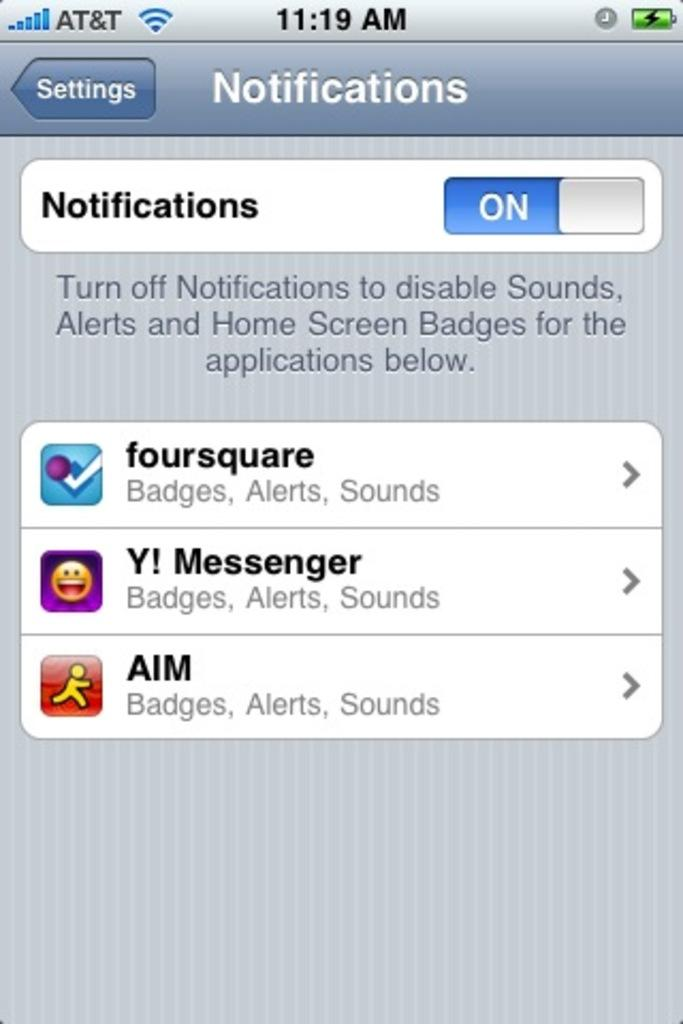<image>
Render a clear and concise summary of the photo. The owner of this phone uses Foursquare, Yahoo Messenger, and AIM. 